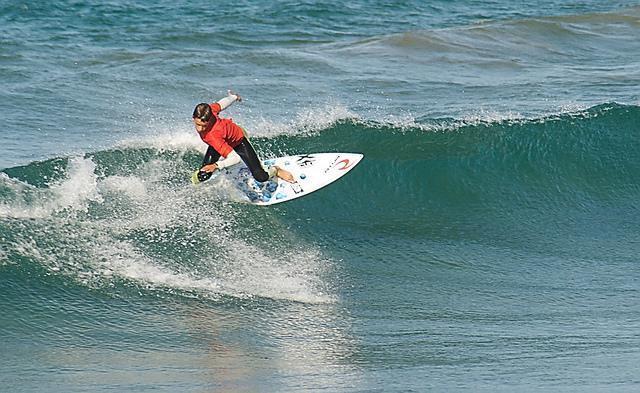How many giraffes are in the picture?
Give a very brief answer. 0. 